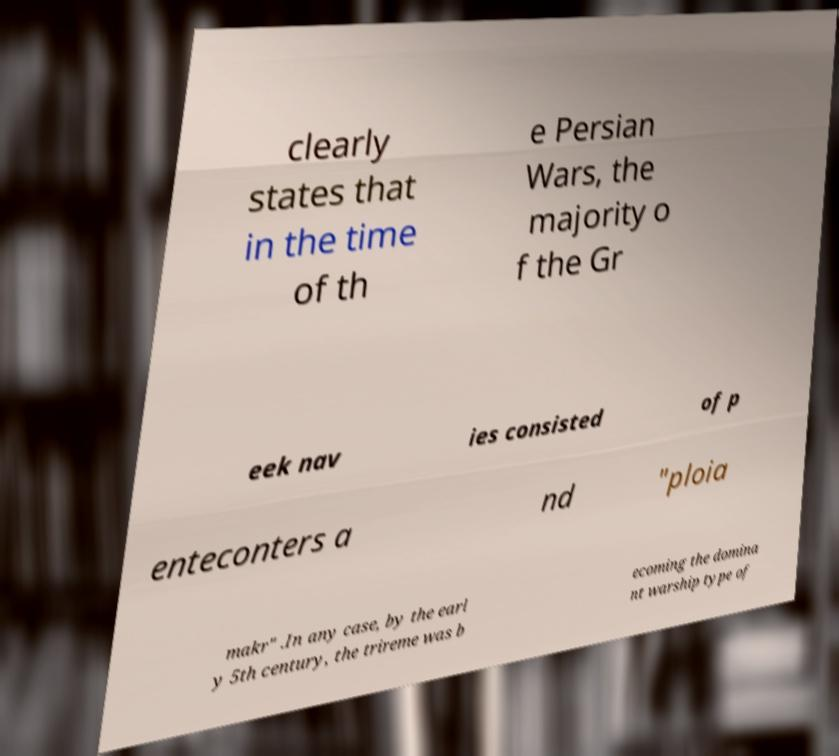Please read and relay the text visible in this image. What does it say? clearly states that in the time of th e Persian Wars, the majority o f the Gr eek nav ies consisted of p enteconters a nd "ploia makr" .In any case, by the earl y 5th century, the trireme was b ecoming the domina nt warship type of 